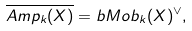Convert formula to latex. <formula><loc_0><loc_0><loc_500><loc_500>\overline { A m p _ { k } ( X ) } = b M o b _ { k } ( X ) ^ { \vee } ,</formula> 